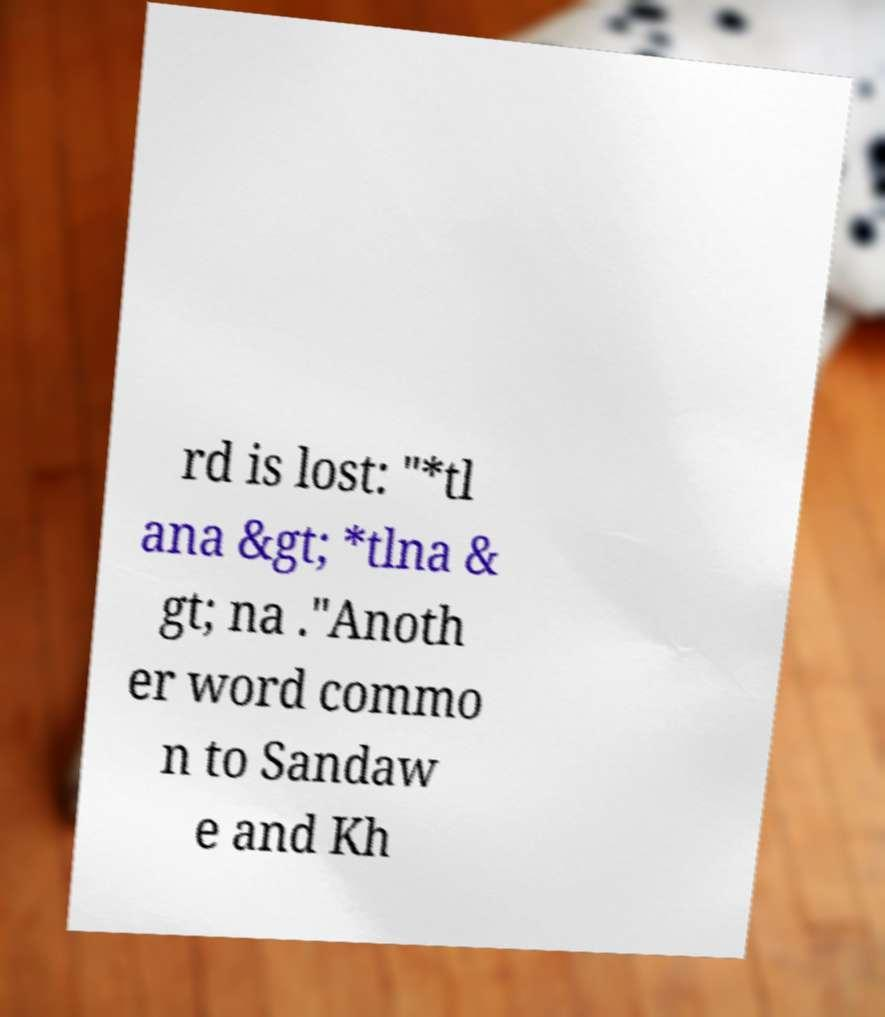What messages or text are displayed in this image? I need them in a readable, typed format. rd is lost: "*tl ana &gt; *tlna & gt; na ."Anoth er word commo n to Sandaw e and Kh 